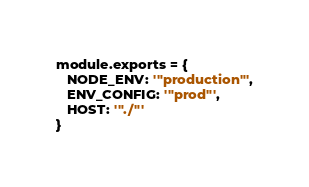Convert code to text. <code><loc_0><loc_0><loc_500><loc_500><_JavaScript_>module.exports = {
   NODE_ENV: '"production"',
   ENV_CONFIG: '"prod"',
   HOST: '"./"'
}
</code> 